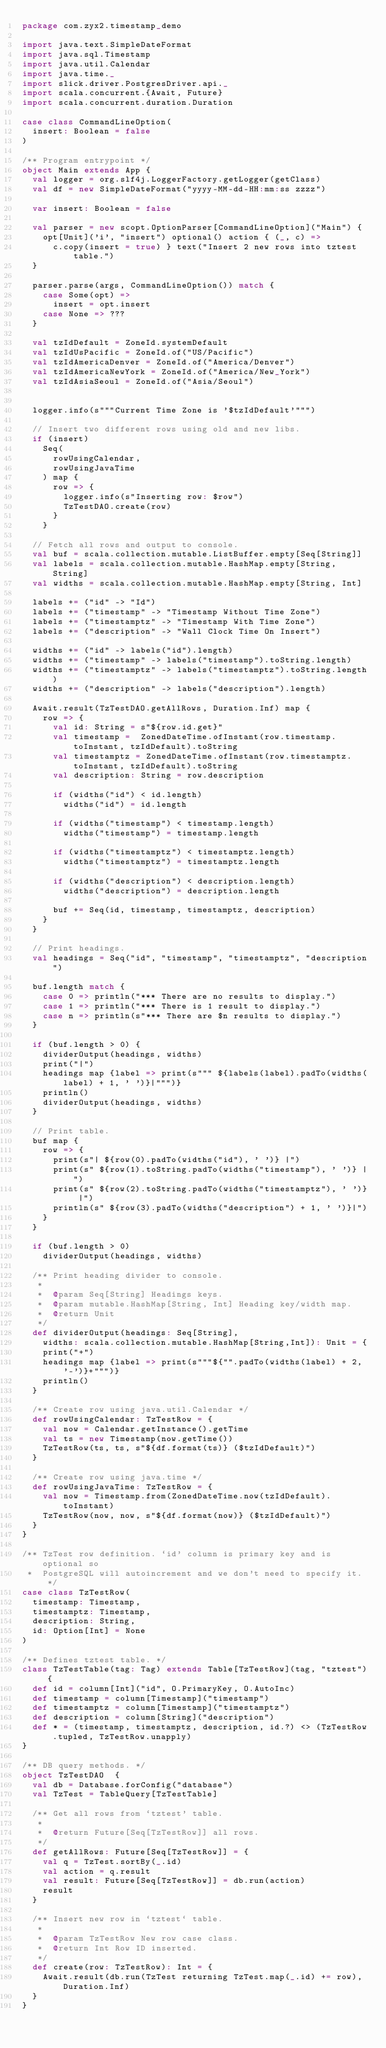<code> <loc_0><loc_0><loc_500><loc_500><_Scala_>package com.zyx2.timestamp_demo

import java.text.SimpleDateFormat
import java.sql.Timestamp
import java.util.Calendar
import java.time._
import slick.driver.PostgresDriver.api._
import scala.concurrent.{Await, Future}
import scala.concurrent.duration.Duration

case class CommandLineOption(
  insert: Boolean = false
)

/** Program entrypoint */
object Main extends App {
  val logger = org.slf4j.LoggerFactory.getLogger(getClass)
  val df = new SimpleDateFormat("yyyy-MM-dd-HH:mm:ss zzzz")

  var insert: Boolean = false

  val parser = new scopt.OptionParser[CommandLineOption]("Main") {
    opt[Unit]('i', "insert") optional() action { (_, c) =>
      c.copy(insert = true) } text("Insert 2 new rows into tztest table.")
  }

  parser.parse(args, CommandLineOption()) match {
    case Some(opt) =>
      insert = opt.insert
    case None => ???
  }

  val tzIdDefault = ZoneId.systemDefault
  val tzIdUsPacific = ZoneId.of("US/Pacific")
  val tzIdAmericaDenver = ZoneId.of("America/Denver")
  val tzIdAmericaNewYork = ZoneId.of("America/New_York")
  val tzIdAsiaSeoul = ZoneId.of("Asia/Seoul")


  logger.info(s"""Current Time Zone is '$tzIdDefault'""")

  // Insert two different rows using old and new libs.
  if (insert)
    Seq(
      rowUsingCalendar,
      rowUsingJavaTime
    ) map {
      row => {
        logger.info(s"Inserting row: $row")
        TzTestDAO.create(row)
      }
    }

  // Fetch all rows and output to console.
  val buf = scala.collection.mutable.ListBuffer.empty[Seq[String]]
  val labels = scala.collection.mutable.HashMap.empty[String, String]
  val widths = scala.collection.mutable.HashMap.empty[String, Int]

  labels += ("id" -> "Id")
  labels += ("timestamp" -> "Timestamp Without Time Zone")
  labels += ("timestamptz" -> "Timestamp With Time Zone")
  labels += ("description" -> "Wall Clock Time On Insert")

  widths += ("id" -> labels("id").length)
  widths += ("timestamp" -> labels("timestamp").toString.length)
  widths += ("timestamptz" -> labels("timestamptz").toString.length)
  widths += ("description" -> labels("description").length)

  Await.result(TzTestDAO.getAllRows, Duration.Inf) map {
    row => {
      val id: String = s"${row.id.get}"
      val timestamp =  ZonedDateTime.ofInstant(row.timestamp.toInstant, tzIdDefault).toString
      val timestamptz = ZonedDateTime.ofInstant(row.timestamptz.toInstant, tzIdDefault).toString
      val description: String = row.description

      if (widths("id") < id.length)
        widths("id") = id.length

      if (widths("timestamp") < timestamp.length)
        widths("timestamp") = timestamp.length

      if (widths("timestamptz") < timestamptz.length)
        widths("timestamptz") = timestamptz.length

      if (widths("description") < description.length)
        widths("description") = description.length

      buf += Seq(id, timestamp, timestamptz, description)
    }
  }

  // Print headings.
  val headings = Seq("id", "timestamp", "timestamptz", "description")

  buf.length match {
    case 0 => println("*** There are no results to display.")
    case 1 => println("*** There is 1 result to display.")
    case n => println(s"*** There are $n results to display.")
  }

  if (buf.length > 0) {
    dividerOutput(headings, widths)
    print("|")
    headings map {label => print(s""" ${labels(label).padTo(widths(label) + 1, ' ')}|""")}
    println()
    dividerOutput(headings, widths)
  }

  // Print table.
  buf map {
    row => {
      print(s"| ${row(0).padTo(widths("id"), ' ')} |")
      print(s" ${row(1).toString.padTo(widths("timestamp"), ' ')} |")
      print(s" ${row(2).toString.padTo(widths("timestamptz"), ' ')} |")
      println(s" ${row(3).padTo(widths("description") + 1, ' ')}|")
    }
  }

  if (buf.length > 0)
    dividerOutput(headings, widths)

  /** Print heading divider to console.
   *
   *  @param Seq[String] Headings keys.
   *  @param mutable.HashMap[String, Int] Heading key/width map.
   *  @return Unit
   */
  def dividerOutput(headings: Seq[String],
    widths: scala.collection.mutable.HashMap[String,Int]): Unit = {
    print("+")
    headings map {label => print(s"""${"".padTo(widths(label) + 2, '-')}+""")}
    println()
  }

  /** Create row using java.util.Calendar */
  def rowUsingCalendar: TzTestRow = {
    val now = Calendar.getInstance().getTime
    val ts = new Timestamp(now.getTime())
    TzTestRow(ts, ts, s"${df.format(ts)} ($tzIdDefault)")
  }

  /** Create row using java.time */
  def rowUsingJavaTime: TzTestRow = {
    val now = Timestamp.from(ZonedDateTime.now(tzIdDefault).toInstant)
    TzTestRow(now, now, s"${df.format(now)} ($tzIdDefault)")
  }
}

/** TzTest row definition. `id' column is primary key and is optional so
 *  PostgreSQL will autoincrement and we don't need to specify it. */
case class TzTestRow(
  timestamp: Timestamp,
  timestamptz: Timestamp,
  description: String,
  id: Option[Int] = None
)

/** Defines tztest table. */
class TzTestTable(tag: Tag) extends Table[TzTestRow](tag, "tztest") {
  def id = column[Int]("id", O.PrimaryKey, O.AutoInc)
  def timestamp = column[Timestamp]("timestamp")
  def timestamptz = column[Timestamp]("timestamptz")
  def description = column[String]("description")
  def * = (timestamp, timestamptz, description, id.?) <> (TzTestRow.tupled, TzTestRow.unapply)
}

/** DB query methods. */
object TzTestDAO  {
  val db = Database.forConfig("database")
  val TzTest = TableQuery[TzTestTable]

  /** Get all rows from `tztest' table.
   *
   *  @return Future[Seq[TzTestRow]] all rows.
   */
  def getAllRows: Future[Seq[TzTestRow]] = {
    val q = TzTest.sortBy(_.id)
    val action = q.result
    val result: Future[Seq[TzTestRow]] = db.run(action)
    result
  }

  /** Insert new row in `tztest` table.
   *
   *  @param TzTestRow New row case class.
   *  @return Int Row ID inserted.
   */
  def create(row: TzTestRow): Int = {
    Await.result(db.run(TzTest returning TzTest.map(_.id) += row), Duration.Inf)
  }
}
</code> 